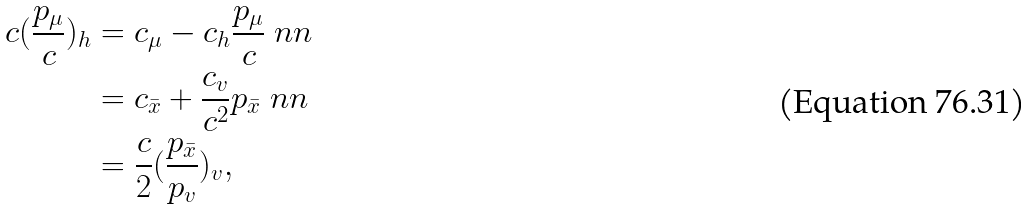<formula> <loc_0><loc_0><loc_500><loc_500>c ( \frac { p _ { \mu } } { c } ) _ { h } & = c _ { \mu } - c _ { h } \frac { p _ { \mu } } { c } \ n n \\ & = c _ { \bar { x } } + \frac { c _ { v } } { c ^ { 2 } } p _ { \bar { x } } \ n n \\ & = \frac { c } { 2 } ( \frac { p _ { \bar { x } } } { p _ { v } } ) _ { v } ,</formula> 